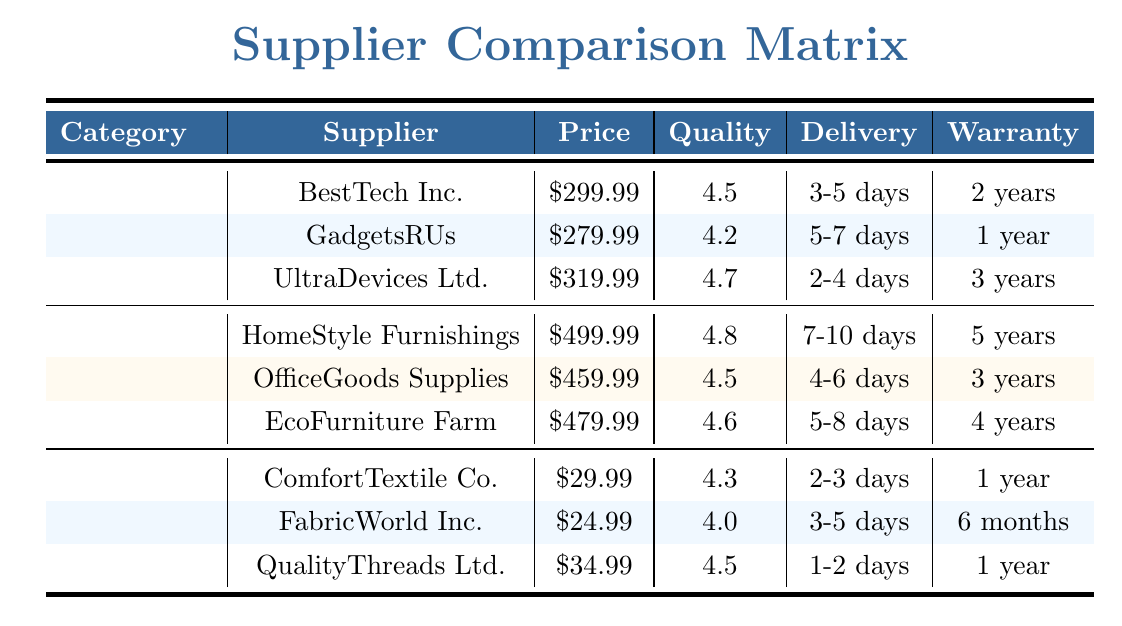What is the price of BestTech Inc. in the Electronics category? BestTech Inc. is listed under the Electronics category, and its price is directly available in the table as 299.99.
Answer: 299.99 Which supplier has the highest Quality Rating in the Furniture category? HomeStyle Furnishings has the highest Quality Rating of 4.8 in the Furniture category when compared to OfficeGoods Supplies (4.5) and EcoFurniture Farm (4.6).
Answer: HomeStyle Furnishings What is the warranty period for GadgetsRUs? GadgetsRUs has a warranty period of 1 year, as indicated in the Warranty column for that supplier in the Electronics category.
Answer: 1 year How much does QualityThreads Ltd. cost compared to FabricWorld Inc.? QualityThreads Ltd. costs 34.99, while FabricWorld Inc. costs 24.99. The difference in price is 34.99 - 24.99 = 10.00, making QualityThreads Ltd. more expensive.
Answer: 10.00 Is there a supplier in Textiles that offers a warranty longer than 1 year? ComfortTextile Co. and QualityThreads Ltd. both have a warranty of 1 year. FabricWorld Inc. has a warranty of 6 months, which is less than 1 year. Thus, there are no suppliers in Textiles offering a warranty longer than 1 year.
Answer: No What is the average price of the suppliers in the Electronics category? To calculate the average price, sum the prices of the suppliers: 299.99 + 279.99 + 319.99 = 899.97. Then, divide by the number of suppliers (3): 899.97 / 3 = 299.99.
Answer: 299.99 Which supplier has the shortest delivery time in the Furniture category? The delivery times for the suppliers in the Furniture category are: HomeStyle Furnishings (7-10 days), OfficeGoods Supplies (4-6 days), and EcoFurniture Farm (5-8 days). OfficeGoods Supplies has the shortest delivery time range.
Answer: OfficeGoods Supplies Are all suppliers in the Textiles category offering a quality rating of 4.0 or higher? The Quality Ratings for the Textiles suppliers are: ComfortTextile Co. (4.3), FabricWorld Inc. (4.0), and QualityThreads Ltd. (4.5). All suppliers have ratings that are 4.0 or higher.
Answer: Yes What is the difference in warranty between HomeStyle Furnishings and EcoFurniture Farm? HomeStyle Furnishings offers a warranty of 5 years, while EcoFurniture Farm offers 4 years. The difference in warranty is 5 - 4 = 1 year.
Answer: 1 year 